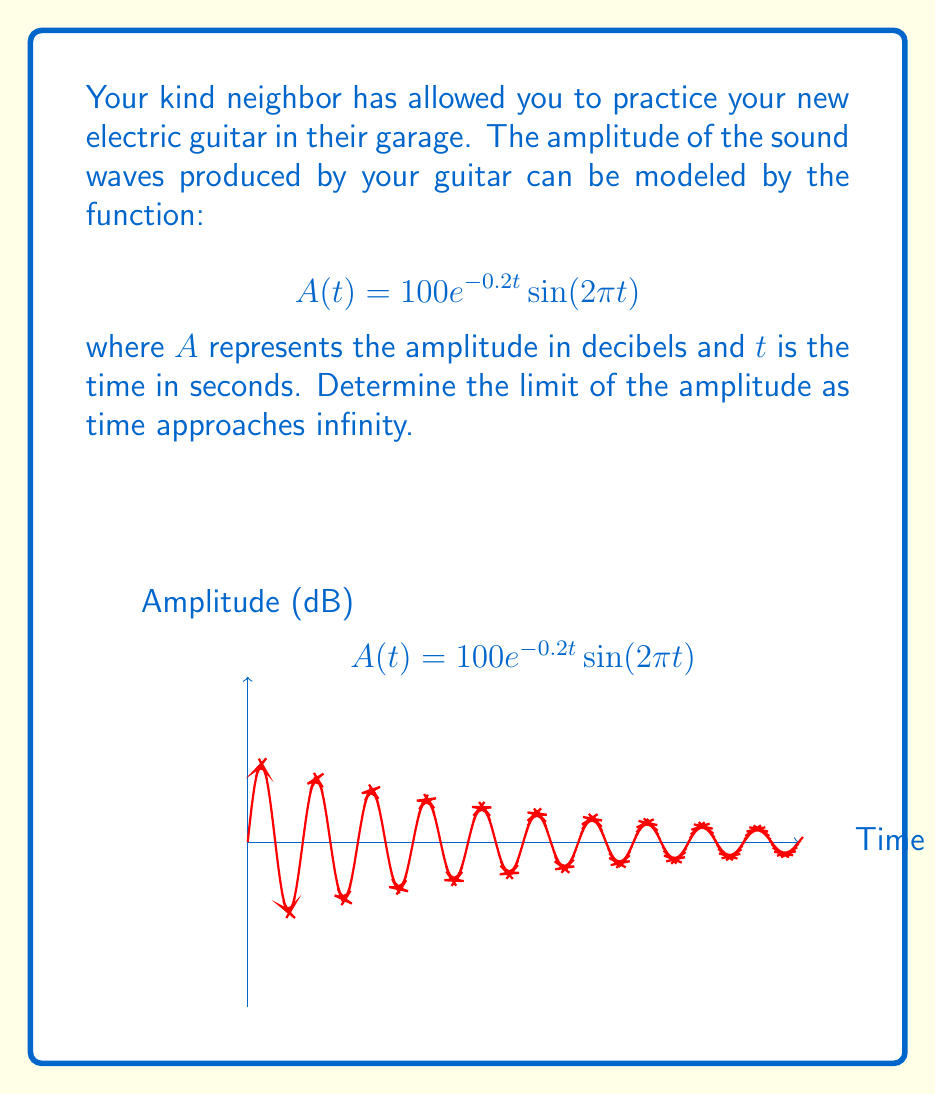Give your solution to this math problem. Let's approach this step-by-step:

1) We need to find $\lim_{t \to \infty} A(t)$, where $A(t) = 100e^{-0.2t}\sin(2\pi t)$.

2) Let's consider the two parts of this function:
   - $100e^{-0.2t}$
   - $\sin(2\pi t)$

3) As $t$ approaches infinity:
   - $e^{-0.2t}$ approaches 0, because the exponent becomes a large negative number.
   - $\sin(2\pi t)$ oscillates between -1 and 1 indefinitely.

4) We can use the limit law for products:
   $$\lim_{t \to \infty} A(t) = \lim_{t \to \infty} 100e^{-0.2t} \cdot \lim_{t \to \infty} \sin(2\pi t)$$

5) We know that:
   $$\lim_{t \to \infty} 100e^{-0.2t} = 0$$
   $$-1 \leq \sin(2\pi t) \leq 1 \text{ for all } t$$

6) Therefore, by the squeeze theorem:
   $$\lim_{t \to \infty} A(t) = 0 \cdot [-1, 1] = 0$$

Thus, as time approaches infinity, the amplitude of the sound waves approaches 0, meaning the sound eventually fades away.
Answer: $0$ 